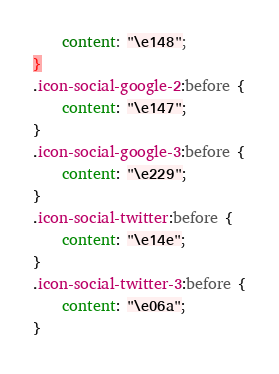<code> <loc_0><loc_0><loc_500><loc_500><_CSS_>	content: "\e148";
}
.icon-social-google-2:before {
	content: "\e147";
}
.icon-social-google-3:before {
	content: "\e229";
}
.icon-social-twitter:before {
	content: "\e14e";
}
.icon-social-twitter-3:before {
	content: "\e06a";
}</code> 